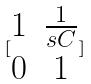Convert formula to latex. <formula><loc_0><loc_0><loc_500><loc_500>[ \begin{matrix} 1 & \frac { 1 } { s C } \\ 0 & 1 \end{matrix} ]</formula> 